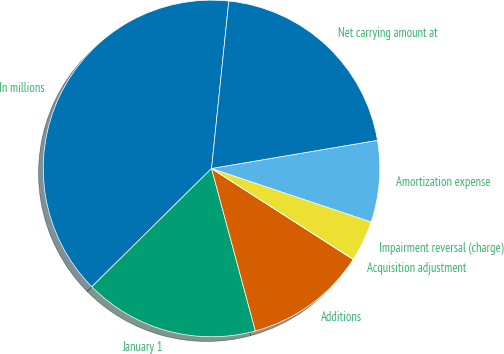<chart> <loc_0><loc_0><loc_500><loc_500><pie_chart><fcel>In millions<fcel>January 1<fcel>Additions<fcel>Acquisition adjustment<fcel>Impairment reversal (charge)<fcel>Amortization expense<fcel>Net carrying amount at<nl><fcel>39.04%<fcel>16.79%<fcel>11.72%<fcel>0.02%<fcel>3.92%<fcel>7.82%<fcel>20.69%<nl></chart> 